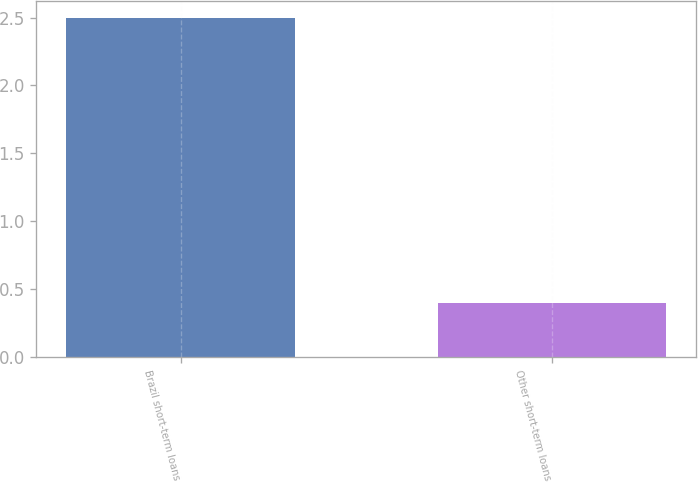Convert chart to OTSL. <chart><loc_0><loc_0><loc_500><loc_500><bar_chart><fcel>Brazil short-term loans<fcel>Other short-term loans<nl><fcel>2.5<fcel>0.4<nl></chart> 